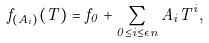Convert formula to latex. <formula><loc_0><loc_0><loc_500><loc_500>f _ { ( A _ { i } ) } ( T ) = f _ { 0 } + \sum _ { 0 \leq i \leq \epsilon n } A _ { i } T ^ { i } ,</formula> 